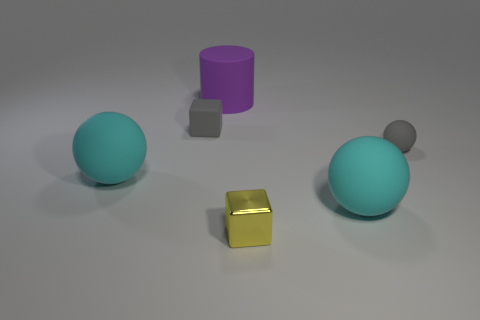There is a small gray rubber thing that is to the left of the small yellow metallic cube; what shape is it?
Offer a terse response. Cube. Is the number of cylinders less than the number of large purple shiny things?
Give a very brief answer. No. Is the tiny block in front of the small ball made of the same material as the gray ball?
Ensure brevity in your answer.  No. Is there anything else that is the same size as the purple thing?
Your response must be concise. Yes. There is a yellow metallic thing; are there any small rubber objects in front of it?
Your answer should be compact. No. There is a block in front of the big cyan rubber thing on the right side of the small object that is in front of the tiny matte ball; what is its color?
Your answer should be very brief. Yellow. What shape is the metal object that is the same size as the gray cube?
Your answer should be very brief. Cube. Are there more rubber balls than purple rubber cylinders?
Offer a very short reply. Yes. Is there a small shiny object to the right of the cyan object on the right side of the purple object?
Give a very brief answer. No. There is another small thing that is the same shape as the tiny yellow shiny thing; what is its color?
Ensure brevity in your answer.  Gray. 